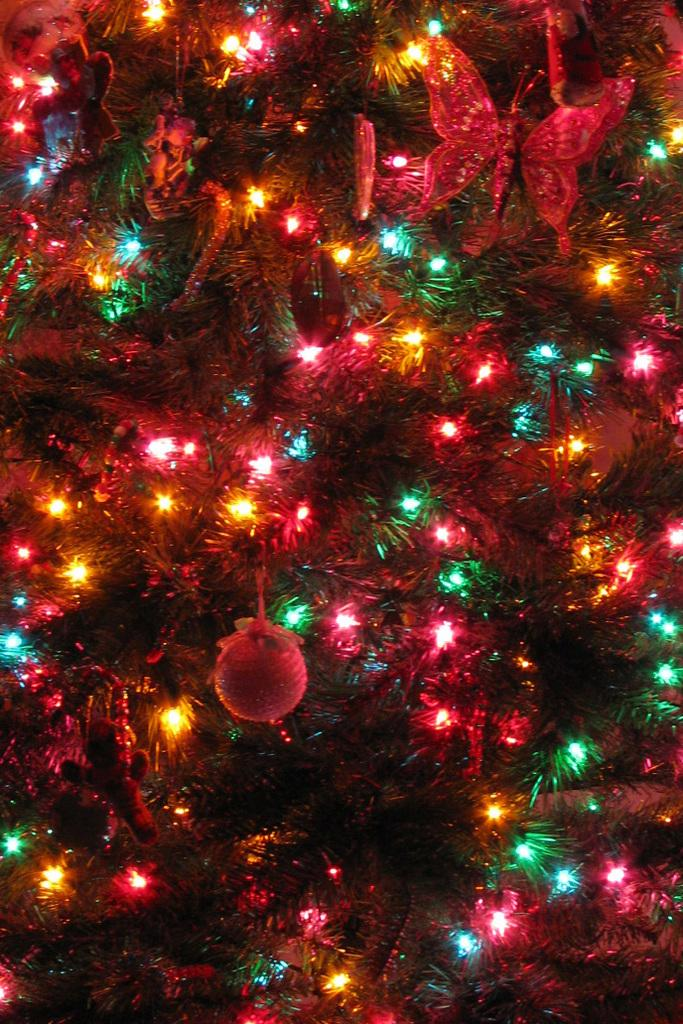What type of tree is in the picture? There is a Christmas tree in the picture. What type of lighting is present in the picture? Decorative lights are present in the picture. What other decorative items can be seen in the picture? Decorative objects are visible in the picture. What type of cakes are being cooked in the picture? There are no cakes or cooking activities present in the image; it features a Christmas tree with decorative lights and objects. 